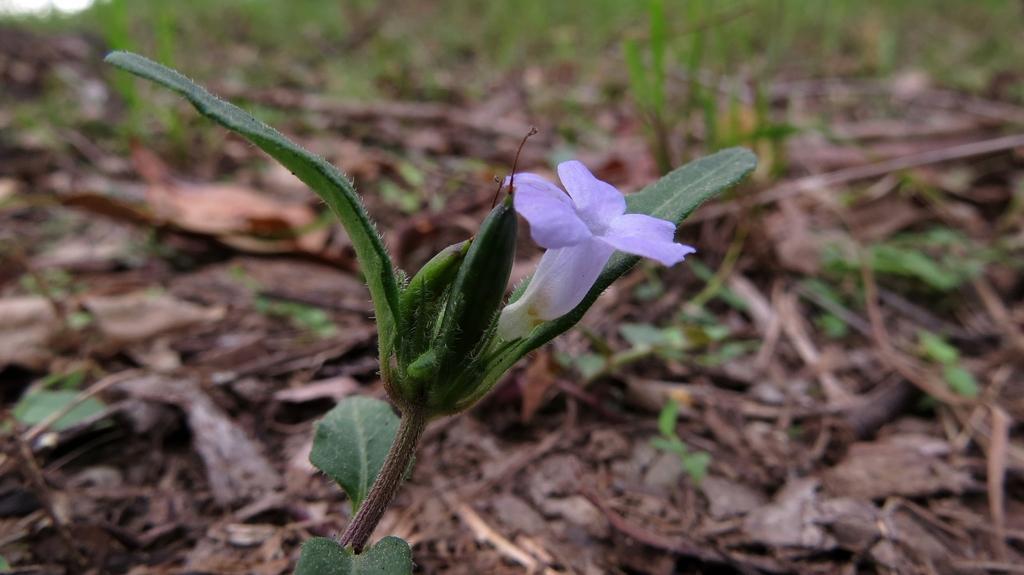Can you describe this image briefly? In this picture we can see a flower and a plant in the front, in the background we can see some leaves, there is a blurry background. 